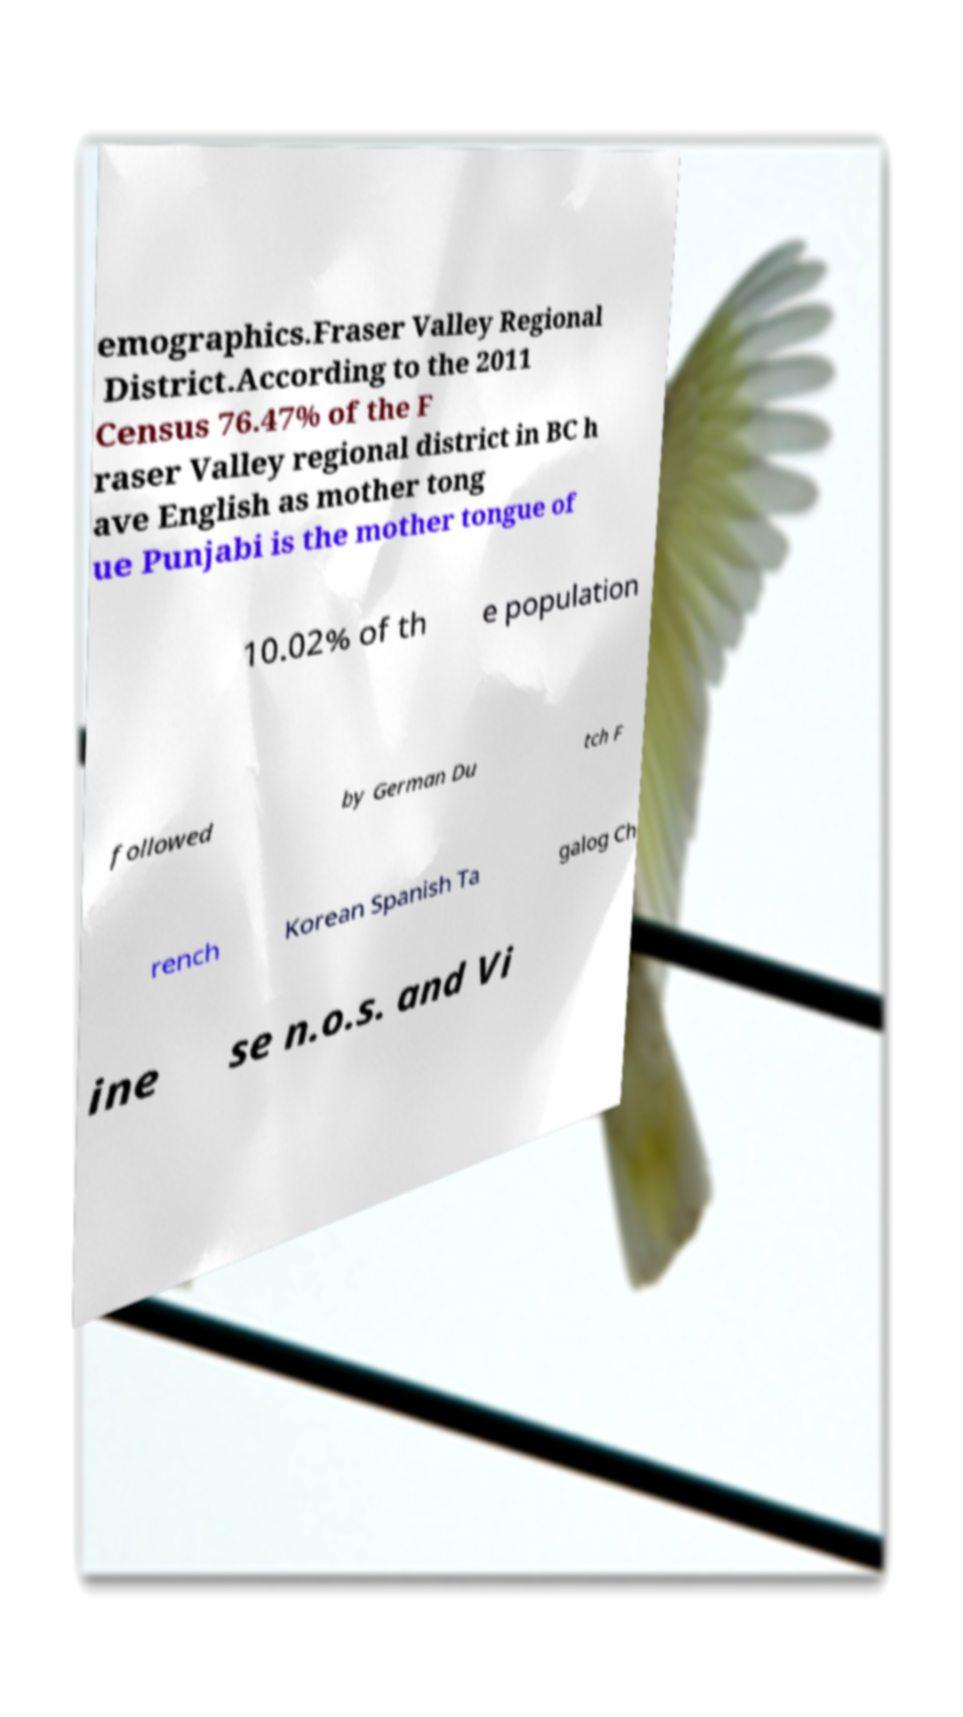Please read and relay the text visible in this image. What does it say? emographics.Fraser Valley Regional District.According to the 2011 Census 76.47% of the F raser Valley regional district in BC h ave English as mother tong ue Punjabi is the mother tongue of 10.02% of th e population followed by German Du tch F rench Korean Spanish Ta galog Ch ine se n.o.s. and Vi 